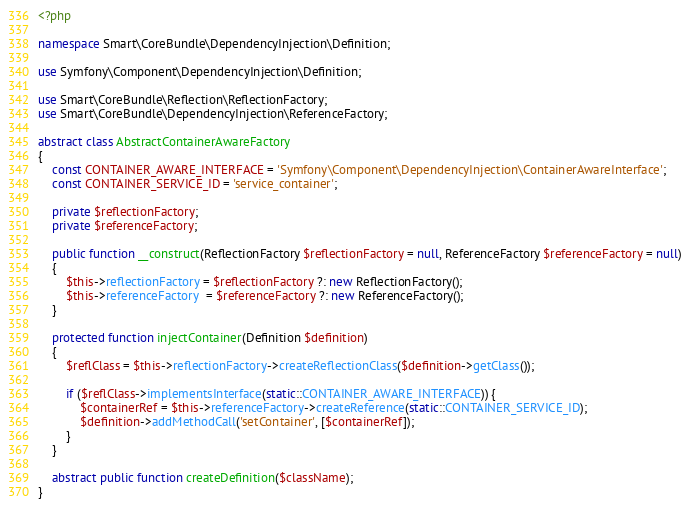<code> <loc_0><loc_0><loc_500><loc_500><_PHP_><?php

namespace Smart\CoreBundle\DependencyInjection\Definition;

use Symfony\Component\DependencyInjection\Definition;

use Smart\CoreBundle\Reflection\ReflectionFactory;
use Smart\CoreBundle\DependencyInjection\ReferenceFactory;

abstract class AbstractContainerAwareFactory
{
    const CONTAINER_AWARE_INTERFACE = 'Symfony\Component\DependencyInjection\ContainerAwareInterface';
    const CONTAINER_SERVICE_ID = 'service_container';

    private $reflectionFactory;
    private $referenceFactory;

    public function __construct(ReflectionFactory $reflectionFactory = null, ReferenceFactory $referenceFactory = null)
    {
        $this->reflectionFactory = $reflectionFactory ?: new ReflectionFactory();
        $this->referenceFactory  = $referenceFactory ?: new ReferenceFactory();
    }

    protected function injectContainer(Definition $definition)
    {
        $reflClass = $this->reflectionFactory->createReflectionClass($definition->getClass());

        if ($reflClass->implementsInterface(static::CONTAINER_AWARE_INTERFACE)) {
            $containerRef = $this->referenceFactory->createReference(static::CONTAINER_SERVICE_ID);
            $definition->addMethodCall('setContainer', [$containerRef]);
        }
    }

    abstract public function createDefinition($className);
}
</code> 